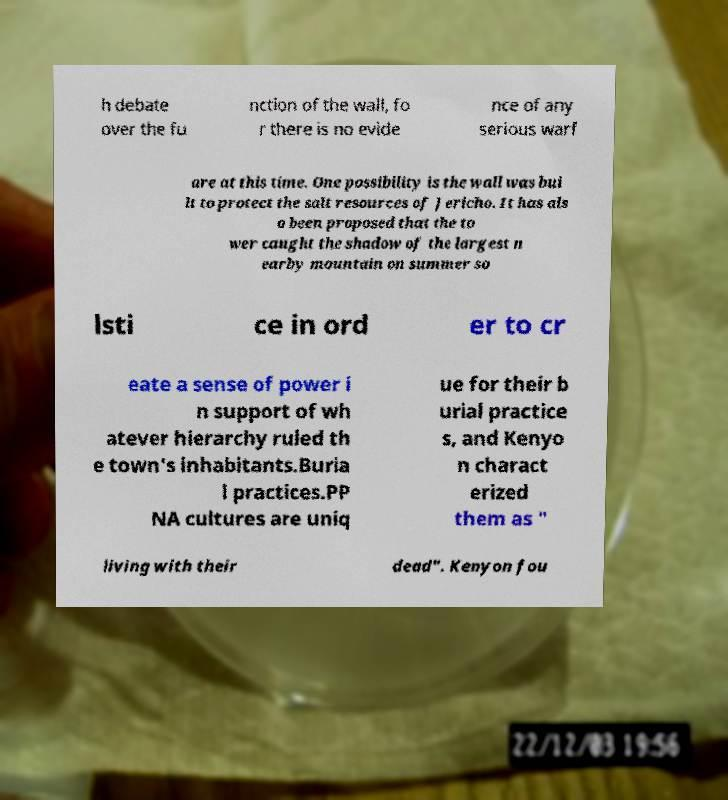Can you accurately transcribe the text from the provided image for me? h debate over the fu nction of the wall, fo r there is no evide nce of any serious warf are at this time. One possibility is the wall was bui lt to protect the salt resources of Jericho. It has als o been proposed that the to wer caught the shadow of the largest n earby mountain on summer so lsti ce in ord er to cr eate a sense of power i n support of wh atever hierarchy ruled th e town's inhabitants.Buria l practices.PP NA cultures are uniq ue for their b urial practice s, and Kenyo n charact erized them as " living with their dead". Kenyon fou 